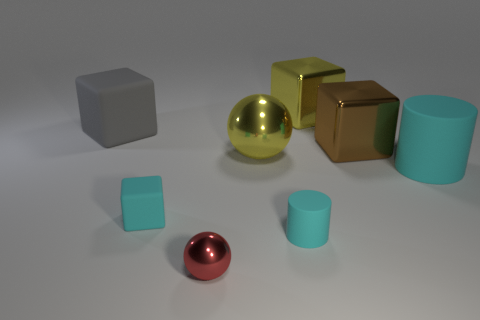Add 2 large metal blocks. How many objects exist? 10 Subtract all big matte blocks. How many blocks are left? 3 Subtract all yellow blocks. How many blocks are left? 3 Subtract all cylinders. How many objects are left? 6 Subtract 1 balls. How many balls are left? 1 Subtract all purple cylinders. How many gray blocks are left? 1 Subtract all cyan cylinders. Subtract all large cyan cylinders. How many objects are left? 5 Add 5 large brown cubes. How many large brown cubes are left? 6 Add 5 big cylinders. How many big cylinders exist? 6 Subtract 0 green cubes. How many objects are left? 8 